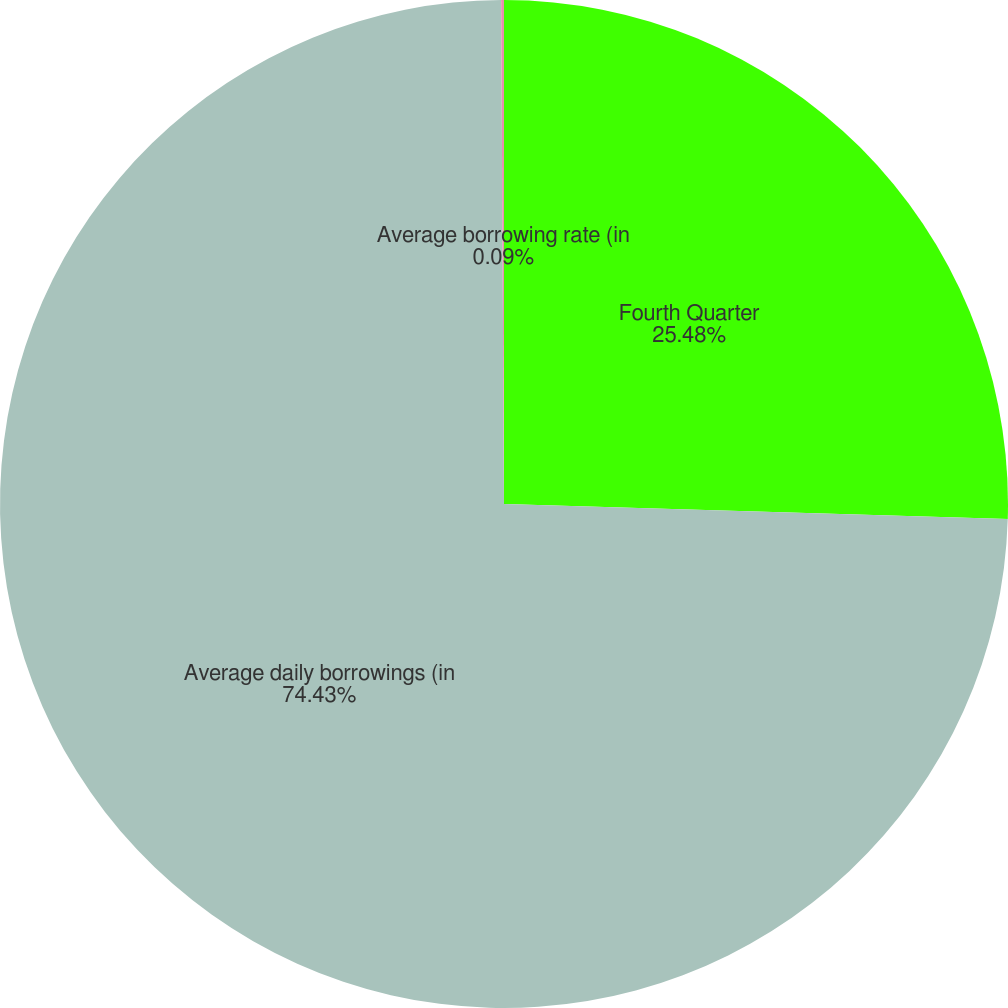<chart> <loc_0><loc_0><loc_500><loc_500><pie_chart><fcel>Fourth Quarter<fcel>Average daily borrowings (in<fcel>Average borrowing rate (in<nl><fcel>25.48%<fcel>74.44%<fcel>0.09%<nl></chart> 